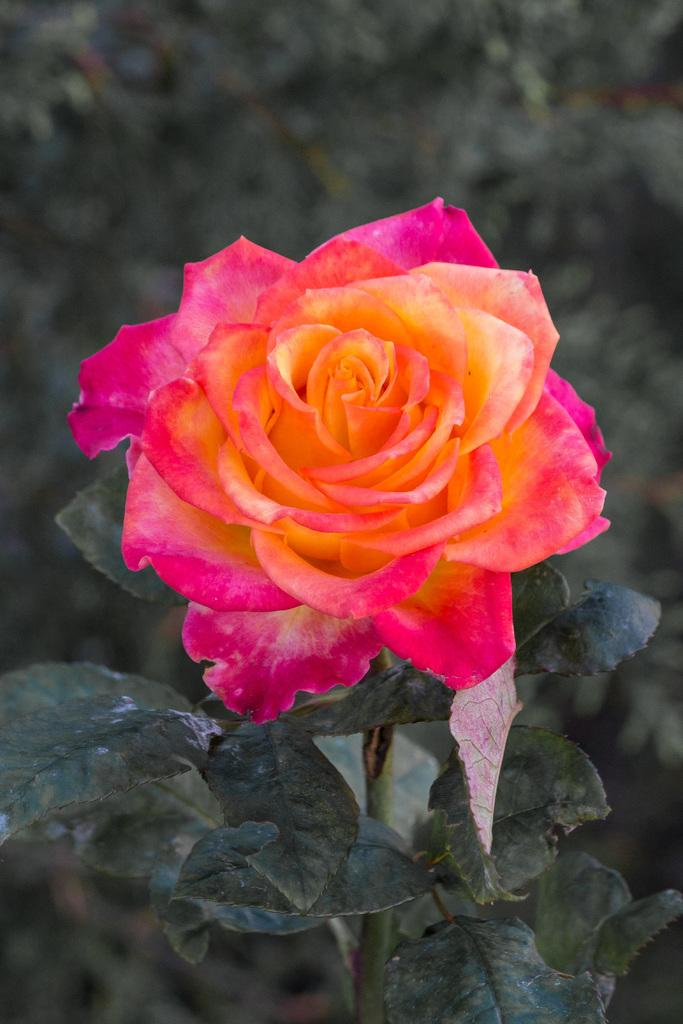What type of flower is in the image? There is a rose flower in the image. Where is the rose flower located? The rose flower is on the stem of a plant. How many teeth can be seen on the rake in the image? There is no rake present in the image, so it is not possible to determine how many teeth might be on a rake. 